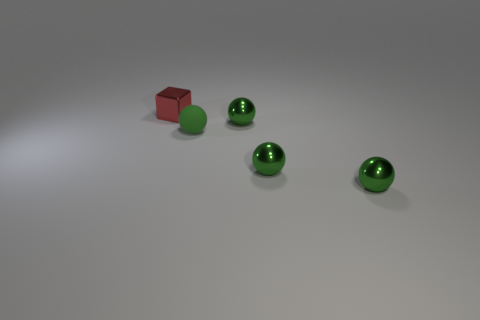There is a object to the left of the matte sphere; is it the same size as the small rubber object?
Keep it short and to the point. Yes. What number of other objects are there of the same color as the rubber ball?
Your answer should be very brief. 3. What is the material of the small block?
Provide a short and direct response. Metal. There is a small thing that is behind the tiny rubber sphere and in front of the small cube; what is its material?
Ensure brevity in your answer.  Metal. What number of things are either balls that are in front of the small green rubber object or small red cubes?
Provide a short and direct response. 3. Is the color of the shiny block the same as the rubber thing?
Provide a short and direct response. No. Are there any things that have the same size as the metallic cube?
Your response must be concise. Yes. How many small metal things are both to the right of the tiny shiny block and behind the small green rubber ball?
Your answer should be very brief. 1. How many green things are behind the green rubber thing?
Your response must be concise. 1. Are there any other objects of the same shape as the red thing?
Your answer should be very brief. No. 